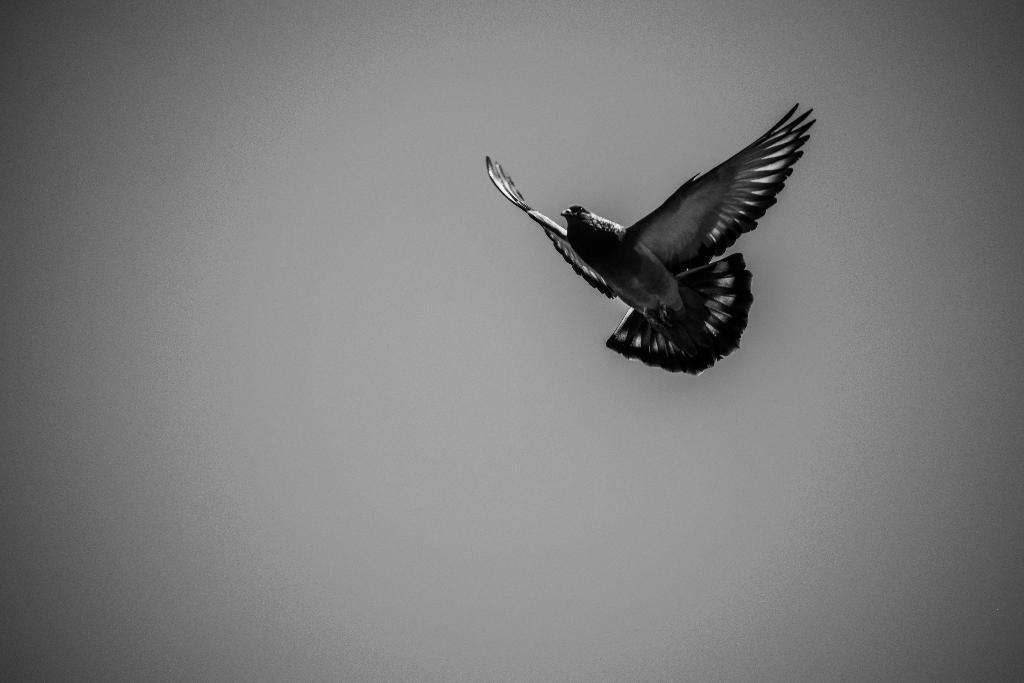Could you give a brief overview of what you see in this image? In this image, we can see a bird flying. 